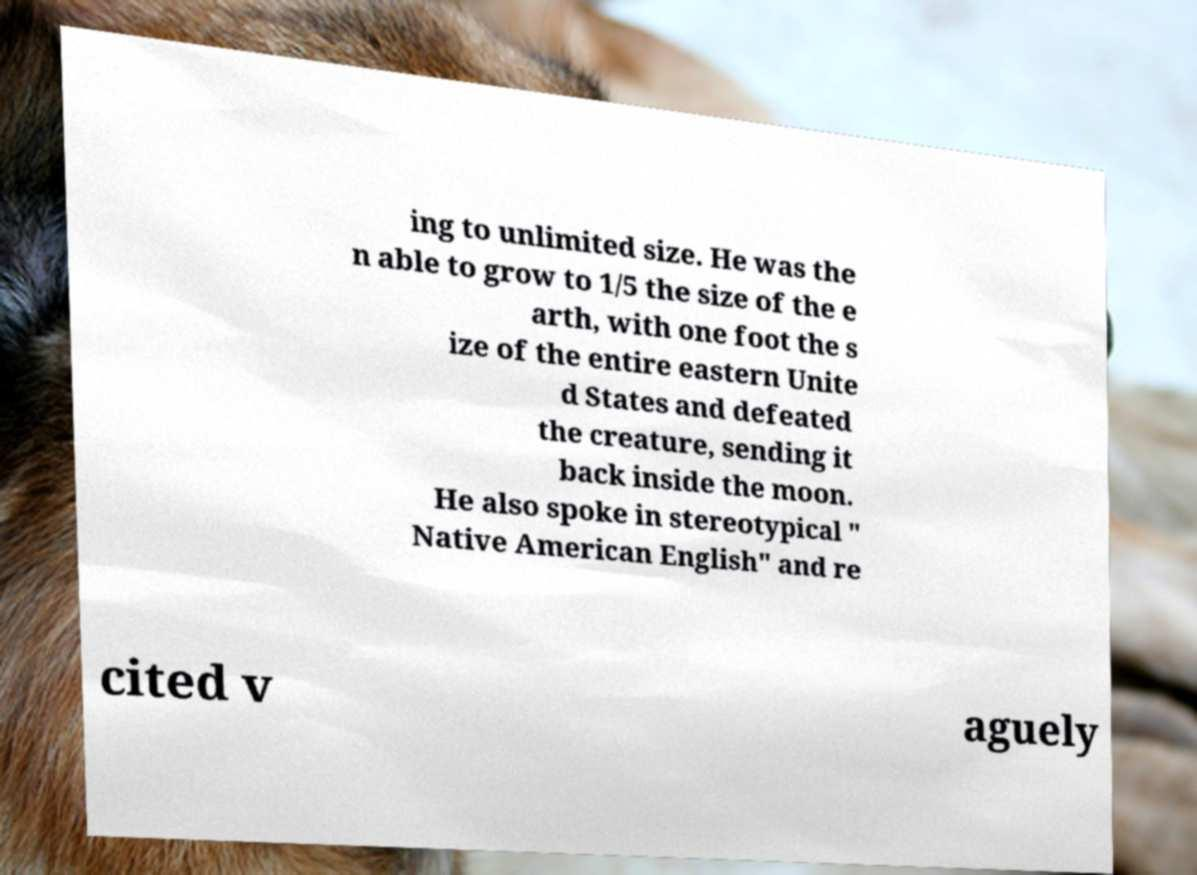There's text embedded in this image that I need extracted. Can you transcribe it verbatim? ing to unlimited size. He was the n able to grow to 1/5 the size of the e arth, with one foot the s ize of the entire eastern Unite d States and defeated the creature, sending it back inside the moon. He also spoke in stereotypical " Native American English" and re cited v aguely 